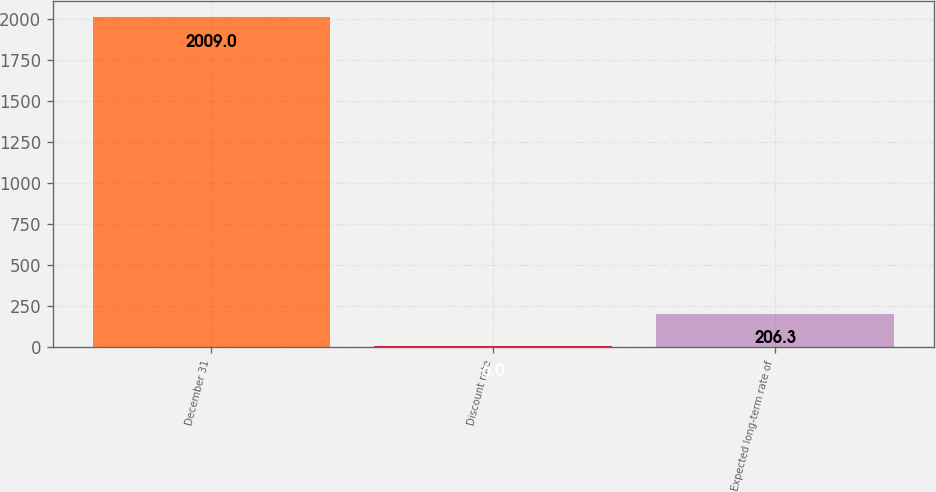Convert chart to OTSL. <chart><loc_0><loc_0><loc_500><loc_500><bar_chart><fcel>December 31<fcel>Discount rate<fcel>Expected long-term rate of<nl><fcel>2009<fcel>6<fcel>206.3<nl></chart> 